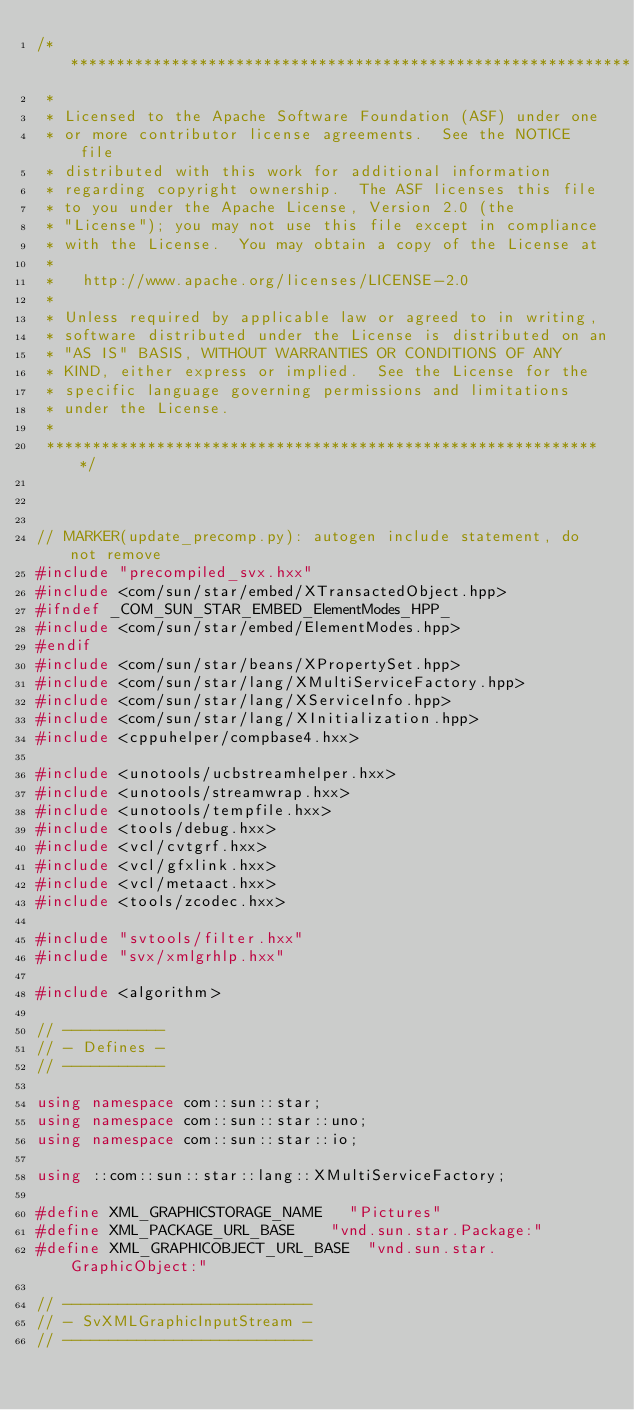Convert code to text. <code><loc_0><loc_0><loc_500><loc_500><_C++_>/**************************************************************
 * 
 * Licensed to the Apache Software Foundation (ASF) under one
 * or more contributor license agreements.  See the NOTICE file
 * distributed with this work for additional information
 * regarding copyright ownership.  The ASF licenses this file
 * to you under the Apache License, Version 2.0 (the
 * "License"); you may not use this file except in compliance
 * with the License.  You may obtain a copy of the License at
 * 
 *   http://www.apache.org/licenses/LICENSE-2.0
 * 
 * Unless required by applicable law or agreed to in writing,
 * software distributed under the License is distributed on an
 * "AS IS" BASIS, WITHOUT WARRANTIES OR CONDITIONS OF ANY
 * KIND, either express or implied.  See the License for the
 * specific language governing permissions and limitations
 * under the License.
 * 
 *************************************************************/



// MARKER(update_precomp.py): autogen include statement, do not remove
#include "precompiled_svx.hxx"
#include <com/sun/star/embed/XTransactedObject.hpp>
#ifndef _COM_SUN_STAR_EMBED_ElementModes_HPP_
#include <com/sun/star/embed/ElementModes.hpp>
#endif
#include <com/sun/star/beans/XPropertySet.hpp>
#include <com/sun/star/lang/XMultiServiceFactory.hpp>
#include <com/sun/star/lang/XServiceInfo.hpp>
#include <com/sun/star/lang/XInitialization.hpp>
#include <cppuhelper/compbase4.hxx>

#include <unotools/ucbstreamhelper.hxx>
#include <unotools/streamwrap.hxx>
#include <unotools/tempfile.hxx>
#include <tools/debug.hxx>
#include <vcl/cvtgrf.hxx>
#include <vcl/gfxlink.hxx>
#include <vcl/metaact.hxx>
#include <tools/zcodec.hxx>

#include "svtools/filter.hxx"
#include "svx/xmlgrhlp.hxx"

#include <algorithm>

// -----------
// - Defines -
// -----------

using namespace com::sun::star;
using namespace com::sun::star::uno;
using namespace com::sun::star::io;

using ::com::sun::star::lang::XMultiServiceFactory;

#define XML_GRAPHICSTORAGE_NAME		"Pictures"
#define XML_PACKAGE_URL_BASE		"vnd.sun.star.Package:"
#define XML_GRAPHICOBJECT_URL_BASE	"vnd.sun.star.GraphicObject:"

// ---------------------------
// - SvXMLGraphicInputStream -
// ---------------------------
</code> 